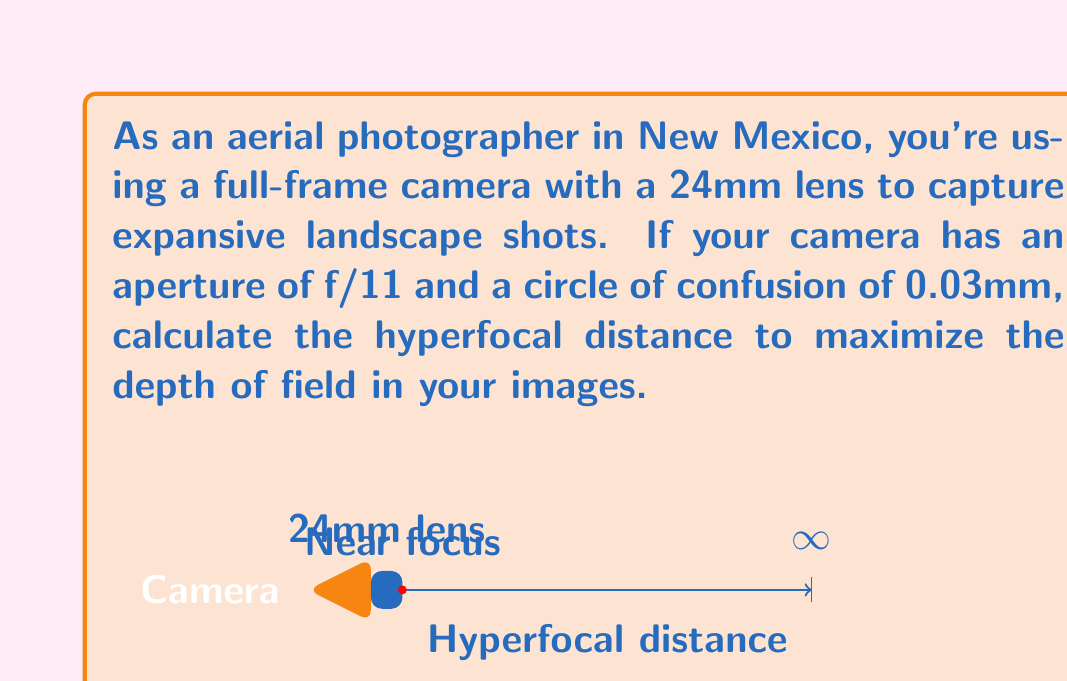Can you answer this question? To calculate the hyperfocal distance, we'll use the formula:

$$H = \frac{f^2}{N \cdot c} + f$$

Where:
$H$ = Hyperfocal distance
$f$ = Focal length
$N$ = f-number (aperture)
$c$ = Circle of confusion

Given:
- Focal length $(f) = 24\text{ mm}$
- Aperture $(N) = f/11$
- Circle of confusion $(c) = 0.03\text{ mm}$

Let's substitute these values into the formula:

$$\begin{align}
H &= \frac{(24\text{ mm})^2}{11 \cdot 0.03\text{ mm}} + 24\text{ mm} \\[10pt]
&= \frac{576\text{ mm}^2}{0.33\text{ mm}} + 24\text{ mm} \\[10pt]
&= 1745.45\text{ mm} + 24\text{ mm} \\[10pt]
&= 1769.45\text{ mm}
\end{align}$$

Converting to meters:

$$1769.45\text{ mm} \approx 1.77\text{ m}$$

Therefore, the hyperfocal distance for maximizing depth of field in your landscape shots is approximately 1.77 meters.
Answer: $1.77\text{ m}$ 